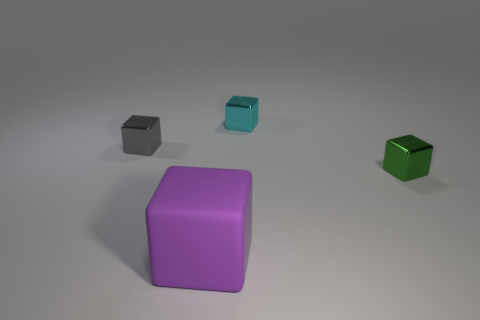What is the color of the large block?
Keep it short and to the point. Purple. How many metallic cubes are the same color as the rubber cube?
Offer a terse response. 0. There is a cyan block that is the same size as the green metal object; what is its material?
Keep it short and to the point. Metal. There is a metallic cube on the left side of the rubber block; are there any purple rubber cubes that are to the left of it?
Provide a short and direct response. No. What size is the cyan metal block?
Offer a very short reply. Small. Is there a green cylinder?
Offer a very short reply. No. Are there more blocks that are in front of the green object than tiny green objects that are behind the tiny cyan metal block?
Provide a short and direct response. Yes. What material is the object that is on the left side of the tiny green thing and in front of the tiny gray metal block?
Offer a terse response. Rubber. Is there anything else that has the same size as the rubber object?
Offer a terse response. No. How many small green shiny things are behind the big purple matte block?
Make the answer very short. 1. 